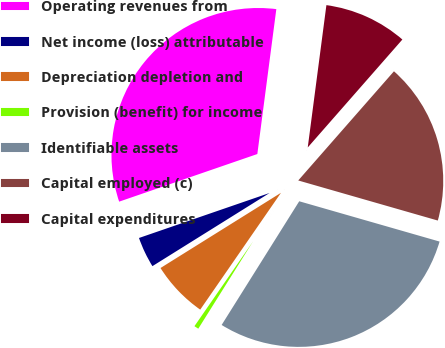Convert chart. <chart><loc_0><loc_0><loc_500><loc_500><pie_chart><fcel>Operating revenues from<fcel>Net income (loss) attributable<fcel>Depreciation depletion and<fcel>Provision (benefit) for income<fcel>Identifiable assets<fcel>Capital employed (c)<fcel>Capital expenditures<nl><fcel>32.35%<fcel>3.6%<fcel>6.49%<fcel>0.71%<fcel>29.46%<fcel>17.99%<fcel>9.38%<nl></chart> 